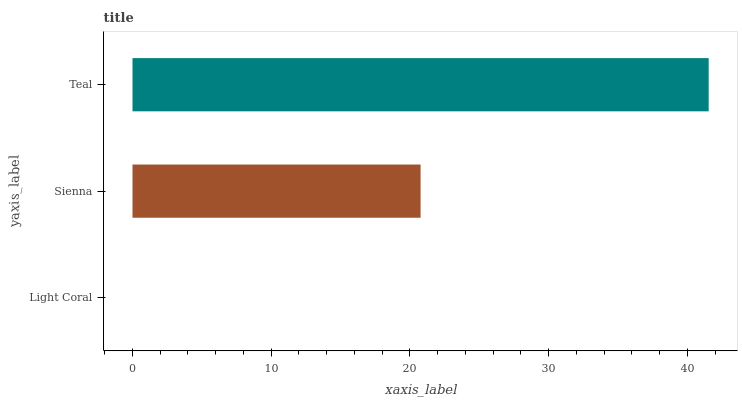Is Light Coral the minimum?
Answer yes or no. Yes. Is Teal the maximum?
Answer yes or no. Yes. Is Sienna the minimum?
Answer yes or no. No. Is Sienna the maximum?
Answer yes or no. No. Is Sienna greater than Light Coral?
Answer yes or no. Yes. Is Light Coral less than Sienna?
Answer yes or no. Yes. Is Light Coral greater than Sienna?
Answer yes or no. No. Is Sienna less than Light Coral?
Answer yes or no. No. Is Sienna the high median?
Answer yes or no. Yes. Is Sienna the low median?
Answer yes or no. Yes. Is Light Coral the high median?
Answer yes or no. No. Is Teal the low median?
Answer yes or no. No. 